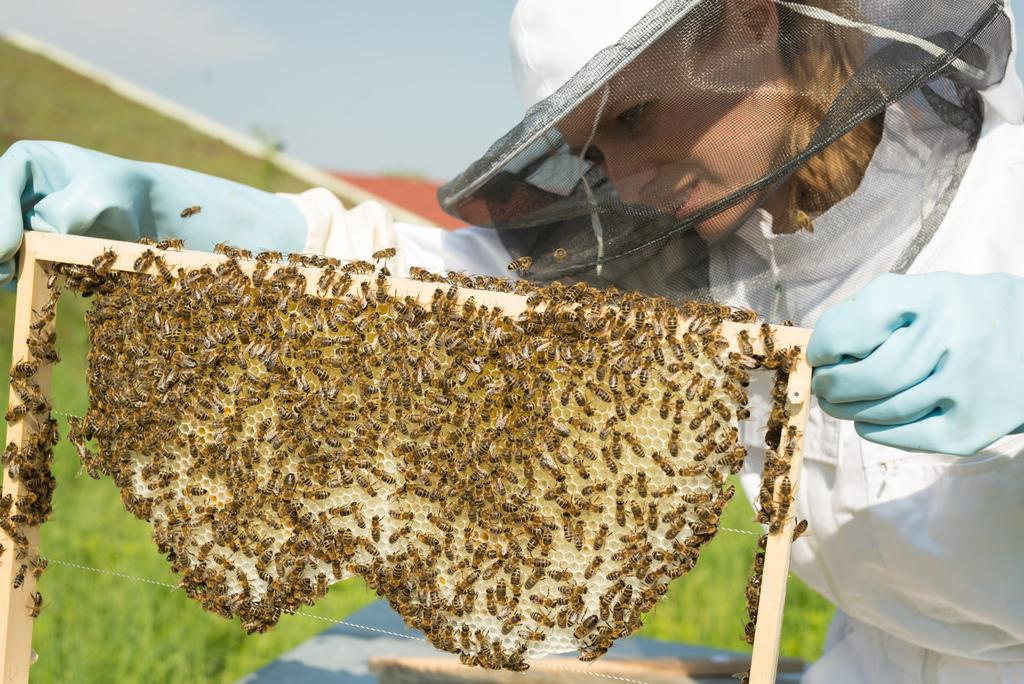Who is the main subject in the image? There is a lady in the image. What is the lady wearing on her head? The lady is wearing a cap. What is the lady wearing on her hands? The lady is wearing gloves. What is the lady holding in the image? The lady is holding a honeycomb. What can be seen on the honeycomb? There are bees on the honeycomb. What type of surface can be seen in the background of the image? There is ground visible in the background of the image. How many brothers does the lady have in the image? There is no information about the lady's brothers in the image. Can you describe the kiss between the lady and the bees in the image? There is no kiss between the lady and the bees in the image; the lady is simply holding the honeycomb with bees on it. 